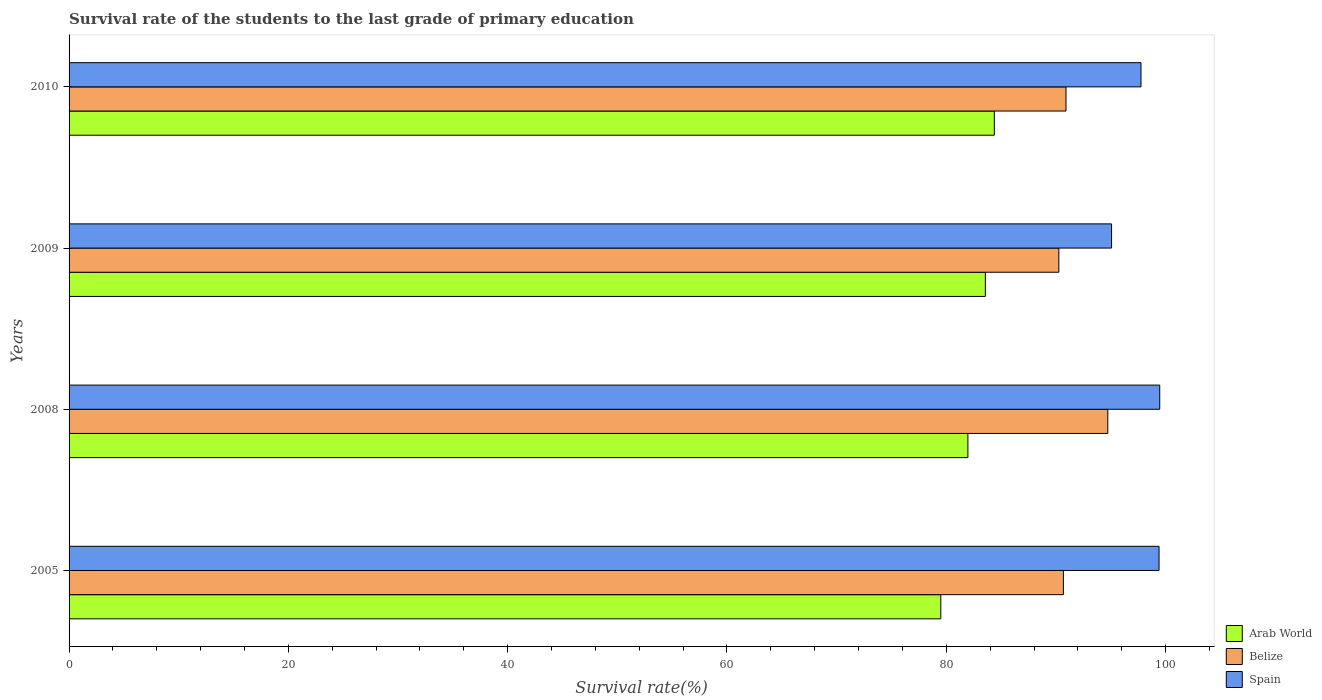How many different coloured bars are there?
Your answer should be very brief. 3. How many groups of bars are there?
Your answer should be very brief. 4. Are the number of bars per tick equal to the number of legend labels?
Provide a succinct answer. Yes. How many bars are there on the 1st tick from the top?
Provide a short and direct response. 3. What is the label of the 1st group of bars from the top?
Provide a short and direct response. 2010. What is the survival rate of the students in Spain in 2005?
Keep it short and to the point. 99.4. Across all years, what is the maximum survival rate of the students in Arab World?
Your answer should be very brief. 84.38. Across all years, what is the minimum survival rate of the students in Arab World?
Provide a succinct answer. 79.5. In which year was the survival rate of the students in Spain maximum?
Provide a succinct answer. 2008. What is the total survival rate of the students in Spain in the graph?
Give a very brief answer. 391.7. What is the difference between the survival rate of the students in Spain in 2008 and that in 2009?
Offer a terse response. 4.39. What is the difference between the survival rate of the students in Arab World in 2009 and the survival rate of the students in Belize in 2008?
Make the answer very short. -11.17. What is the average survival rate of the students in Spain per year?
Make the answer very short. 97.92. In the year 2010, what is the difference between the survival rate of the students in Spain and survival rate of the students in Belize?
Ensure brevity in your answer.  6.84. What is the ratio of the survival rate of the students in Belize in 2008 to that in 2009?
Ensure brevity in your answer.  1.05. Is the survival rate of the students in Spain in 2005 less than that in 2008?
Your response must be concise. Yes. Is the difference between the survival rate of the students in Spain in 2005 and 2009 greater than the difference between the survival rate of the students in Belize in 2005 and 2009?
Make the answer very short. Yes. What is the difference between the highest and the second highest survival rate of the students in Belize?
Provide a succinct answer. 3.81. What is the difference between the highest and the lowest survival rate of the students in Spain?
Provide a succinct answer. 4.39. In how many years, is the survival rate of the students in Arab World greater than the average survival rate of the students in Arab World taken over all years?
Provide a short and direct response. 2. What does the 3rd bar from the top in 2009 represents?
Keep it short and to the point. Arab World. What does the 2nd bar from the bottom in 2010 represents?
Your answer should be very brief. Belize. Is it the case that in every year, the sum of the survival rate of the students in Spain and survival rate of the students in Arab World is greater than the survival rate of the students in Belize?
Make the answer very short. Yes. How many bars are there?
Provide a succinct answer. 12. Are all the bars in the graph horizontal?
Keep it short and to the point. Yes. What is the difference between two consecutive major ticks on the X-axis?
Offer a very short reply. 20. Does the graph contain any zero values?
Offer a terse response. No. Does the graph contain grids?
Provide a succinct answer. No. Where does the legend appear in the graph?
Keep it short and to the point. Bottom right. How are the legend labels stacked?
Make the answer very short. Vertical. What is the title of the graph?
Your answer should be compact. Survival rate of the students to the last grade of primary education. What is the label or title of the X-axis?
Provide a succinct answer. Survival rate(%). What is the Survival rate(%) in Arab World in 2005?
Provide a short and direct response. 79.5. What is the Survival rate(%) of Belize in 2005?
Make the answer very short. 90.68. What is the Survival rate(%) of Spain in 2005?
Your response must be concise. 99.4. What is the Survival rate(%) in Arab World in 2008?
Provide a short and direct response. 81.97. What is the Survival rate(%) of Belize in 2008?
Provide a short and direct response. 94.73. What is the Survival rate(%) of Spain in 2008?
Give a very brief answer. 99.47. What is the Survival rate(%) of Arab World in 2009?
Your answer should be compact. 83.56. What is the Survival rate(%) of Belize in 2009?
Give a very brief answer. 90.27. What is the Survival rate(%) of Spain in 2009?
Provide a short and direct response. 95.07. What is the Survival rate(%) in Arab World in 2010?
Provide a succinct answer. 84.38. What is the Survival rate(%) in Belize in 2010?
Ensure brevity in your answer.  90.92. What is the Survival rate(%) in Spain in 2010?
Your response must be concise. 97.76. Across all years, what is the maximum Survival rate(%) in Arab World?
Your answer should be compact. 84.38. Across all years, what is the maximum Survival rate(%) of Belize?
Give a very brief answer. 94.73. Across all years, what is the maximum Survival rate(%) in Spain?
Your answer should be very brief. 99.47. Across all years, what is the minimum Survival rate(%) in Arab World?
Give a very brief answer. 79.5. Across all years, what is the minimum Survival rate(%) in Belize?
Make the answer very short. 90.27. Across all years, what is the minimum Survival rate(%) in Spain?
Your answer should be very brief. 95.07. What is the total Survival rate(%) in Arab World in the graph?
Provide a short and direct response. 329.41. What is the total Survival rate(%) of Belize in the graph?
Keep it short and to the point. 366.59. What is the total Survival rate(%) of Spain in the graph?
Make the answer very short. 391.7. What is the difference between the Survival rate(%) in Arab World in 2005 and that in 2008?
Provide a succinct answer. -2.47. What is the difference between the Survival rate(%) in Belize in 2005 and that in 2008?
Ensure brevity in your answer.  -4.05. What is the difference between the Survival rate(%) of Spain in 2005 and that in 2008?
Your answer should be compact. -0.06. What is the difference between the Survival rate(%) in Arab World in 2005 and that in 2009?
Keep it short and to the point. -4.06. What is the difference between the Survival rate(%) in Belize in 2005 and that in 2009?
Keep it short and to the point. 0.41. What is the difference between the Survival rate(%) of Spain in 2005 and that in 2009?
Provide a succinct answer. 4.33. What is the difference between the Survival rate(%) of Arab World in 2005 and that in 2010?
Offer a very short reply. -4.88. What is the difference between the Survival rate(%) in Belize in 2005 and that in 2010?
Offer a terse response. -0.24. What is the difference between the Survival rate(%) of Spain in 2005 and that in 2010?
Offer a very short reply. 1.65. What is the difference between the Survival rate(%) in Arab World in 2008 and that in 2009?
Offer a terse response. -1.59. What is the difference between the Survival rate(%) of Belize in 2008 and that in 2009?
Your answer should be very brief. 4.46. What is the difference between the Survival rate(%) of Spain in 2008 and that in 2009?
Offer a terse response. 4.39. What is the difference between the Survival rate(%) in Arab World in 2008 and that in 2010?
Your answer should be very brief. -2.41. What is the difference between the Survival rate(%) of Belize in 2008 and that in 2010?
Offer a very short reply. 3.81. What is the difference between the Survival rate(%) of Spain in 2008 and that in 2010?
Your answer should be compact. 1.71. What is the difference between the Survival rate(%) of Arab World in 2009 and that in 2010?
Your response must be concise. -0.82. What is the difference between the Survival rate(%) in Belize in 2009 and that in 2010?
Keep it short and to the point. -0.65. What is the difference between the Survival rate(%) of Spain in 2009 and that in 2010?
Provide a short and direct response. -2.69. What is the difference between the Survival rate(%) of Arab World in 2005 and the Survival rate(%) of Belize in 2008?
Provide a succinct answer. -15.23. What is the difference between the Survival rate(%) in Arab World in 2005 and the Survival rate(%) in Spain in 2008?
Your response must be concise. -19.97. What is the difference between the Survival rate(%) in Belize in 2005 and the Survival rate(%) in Spain in 2008?
Your response must be concise. -8.79. What is the difference between the Survival rate(%) of Arab World in 2005 and the Survival rate(%) of Belize in 2009?
Your answer should be very brief. -10.77. What is the difference between the Survival rate(%) in Arab World in 2005 and the Survival rate(%) in Spain in 2009?
Keep it short and to the point. -15.57. What is the difference between the Survival rate(%) of Belize in 2005 and the Survival rate(%) of Spain in 2009?
Provide a succinct answer. -4.39. What is the difference between the Survival rate(%) of Arab World in 2005 and the Survival rate(%) of Belize in 2010?
Your answer should be compact. -11.42. What is the difference between the Survival rate(%) in Arab World in 2005 and the Survival rate(%) in Spain in 2010?
Provide a short and direct response. -18.26. What is the difference between the Survival rate(%) in Belize in 2005 and the Survival rate(%) in Spain in 2010?
Your answer should be compact. -7.08. What is the difference between the Survival rate(%) in Arab World in 2008 and the Survival rate(%) in Belize in 2009?
Ensure brevity in your answer.  -8.3. What is the difference between the Survival rate(%) of Arab World in 2008 and the Survival rate(%) of Spain in 2009?
Your answer should be compact. -13.1. What is the difference between the Survival rate(%) of Belize in 2008 and the Survival rate(%) of Spain in 2009?
Make the answer very short. -0.34. What is the difference between the Survival rate(%) in Arab World in 2008 and the Survival rate(%) in Belize in 2010?
Your answer should be compact. -8.95. What is the difference between the Survival rate(%) in Arab World in 2008 and the Survival rate(%) in Spain in 2010?
Make the answer very short. -15.79. What is the difference between the Survival rate(%) in Belize in 2008 and the Survival rate(%) in Spain in 2010?
Keep it short and to the point. -3.03. What is the difference between the Survival rate(%) in Arab World in 2009 and the Survival rate(%) in Belize in 2010?
Offer a very short reply. -7.35. What is the difference between the Survival rate(%) in Arab World in 2009 and the Survival rate(%) in Spain in 2010?
Provide a succinct answer. -14.19. What is the difference between the Survival rate(%) of Belize in 2009 and the Survival rate(%) of Spain in 2010?
Offer a very short reply. -7.49. What is the average Survival rate(%) of Arab World per year?
Your answer should be very brief. 82.35. What is the average Survival rate(%) of Belize per year?
Ensure brevity in your answer.  91.65. What is the average Survival rate(%) in Spain per year?
Make the answer very short. 97.92. In the year 2005, what is the difference between the Survival rate(%) of Arab World and Survival rate(%) of Belize?
Your answer should be compact. -11.18. In the year 2005, what is the difference between the Survival rate(%) of Arab World and Survival rate(%) of Spain?
Provide a succinct answer. -19.9. In the year 2005, what is the difference between the Survival rate(%) in Belize and Survival rate(%) in Spain?
Offer a terse response. -8.72. In the year 2008, what is the difference between the Survival rate(%) of Arab World and Survival rate(%) of Belize?
Provide a succinct answer. -12.76. In the year 2008, what is the difference between the Survival rate(%) of Arab World and Survival rate(%) of Spain?
Keep it short and to the point. -17.5. In the year 2008, what is the difference between the Survival rate(%) in Belize and Survival rate(%) in Spain?
Your answer should be very brief. -4.74. In the year 2009, what is the difference between the Survival rate(%) in Arab World and Survival rate(%) in Belize?
Offer a very short reply. -6.7. In the year 2009, what is the difference between the Survival rate(%) of Arab World and Survival rate(%) of Spain?
Ensure brevity in your answer.  -11.51. In the year 2009, what is the difference between the Survival rate(%) in Belize and Survival rate(%) in Spain?
Keep it short and to the point. -4.81. In the year 2010, what is the difference between the Survival rate(%) in Arab World and Survival rate(%) in Belize?
Your answer should be compact. -6.54. In the year 2010, what is the difference between the Survival rate(%) of Arab World and Survival rate(%) of Spain?
Offer a very short reply. -13.38. In the year 2010, what is the difference between the Survival rate(%) of Belize and Survival rate(%) of Spain?
Your response must be concise. -6.84. What is the ratio of the Survival rate(%) in Arab World in 2005 to that in 2008?
Give a very brief answer. 0.97. What is the ratio of the Survival rate(%) of Belize in 2005 to that in 2008?
Your answer should be very brief. 0.96. What is the ratio of the Survival rate(%) of Spain in 2005 to that in 2008?
Your answer should be compact. 1. What is the ratio of the Survival rate(%) of Arab World in 2005 to that in 2009?
Give a very brief answer. 0.95. What is the ratio of the Survival rate(%) of Spain in 2005 to that in 2009?
Offer a very short reply. 1.05. What is the ratio of the Survival rate(%) in Arab World in 2005 to that in 2010?
Provide a succinct answer. 0.94. What is the ratio of the Survival rate(%) in Belize in 2005 to that in 2010?
Provide a succinct answer. 1. What is the ratio of the Survival rate(%) in Spain in 2005 to that in 2010?
Offer a terse response. 1.02. What is the ratio of the Survival rate(%) in Belize in 2008 to that in 2009?
Your response must be concise. 1.05. What is the ratio of the Survival rate(%) in Spain in 2008 to that in 2009?
Your answer should be compact. 1.05. What is the ratio of the Survival rate(%) of Arab World in 2008 to that in 2010?
Your answer should be very brief. 0.97. What is the ratio of the Survival rate(%) of Belize in 2008 to that in 2010?
Provide a short and direct response. 1.04. What is the ratio of the Survival rate(%) of Spain in 2008 to that in 2010?
Make the answer very short. 1.02. What is the ratio of the Survival rate(%) in Arab World in 2009 to that in 2010?
Make the answer very short. 0.99. What is the ratio of the Survival rate(%) in Spain in 2009 to that in 2010?
Offer a very short reply. 0.97. What is the difference between the highest and the second highest Survival rate(%) of Arab World?
Your response must be concise. 0.82. What is the difference between the highest and the second highest Survival rate(%) in Belize?
Provide a succinct answer. 3.81. What is the difference between the highest and the second highest Survival rate(%) of Spain?
Provide a succinct answer. 0.06. What is the difference between the highest and the lowest Survival rate(%) in Arab World?
Provide a succinct answer. 4.88. What is the difference between the highest and the lowest Survival rate(%) of Belize?
Ensure brevity in your answer.  4.46. What is the difference between the highest and the lowest Survival rate(%) in Spain?
Give a very brief answer. 4.39. 